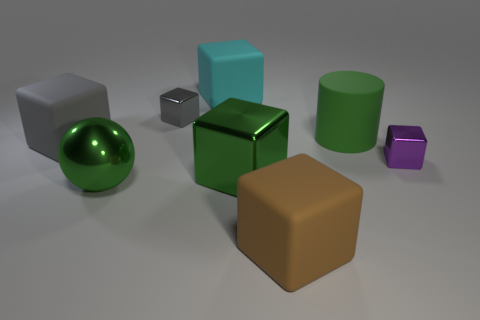How big is the green object on the right side of the rubber block that is in front of the small purple object?
Your answer should be compact. Large. There is a tiny metal cube on the left side of the green cylinder; does it have the same color as the large rubber block to the left of the green shiny ball?
Offer a terse response. Yes. The shiny thing that is both on the left side of the cyan thing and behind the big green block is what color?
Give a very brief answer. Gray. Is the material of the green cube the same as the big green sphere?
Ensure brevity in your answer.  Yes. How many big objects are cyan objects or shiny objects?
Offer a very short reply. 3. Is there anything else that has the same shape as the big green matte object?
Your answer should be compact. No. There is a big ball that is made of the same material as the purple thing; what is its color?
Offer a terse response. Green. There is a thing that is on the right side of the big green cylinder; what is its color?
Provide a succinct answer. Purple. What number of large rubber cubes have the same color as the big rubber cylinder?
Provide a succinct answer. 0. Are there fewer small shiny objects that are right of the purple object than large gray matte cubes that are right of the green matte cylinder?
Your answer should be very brief. No. 